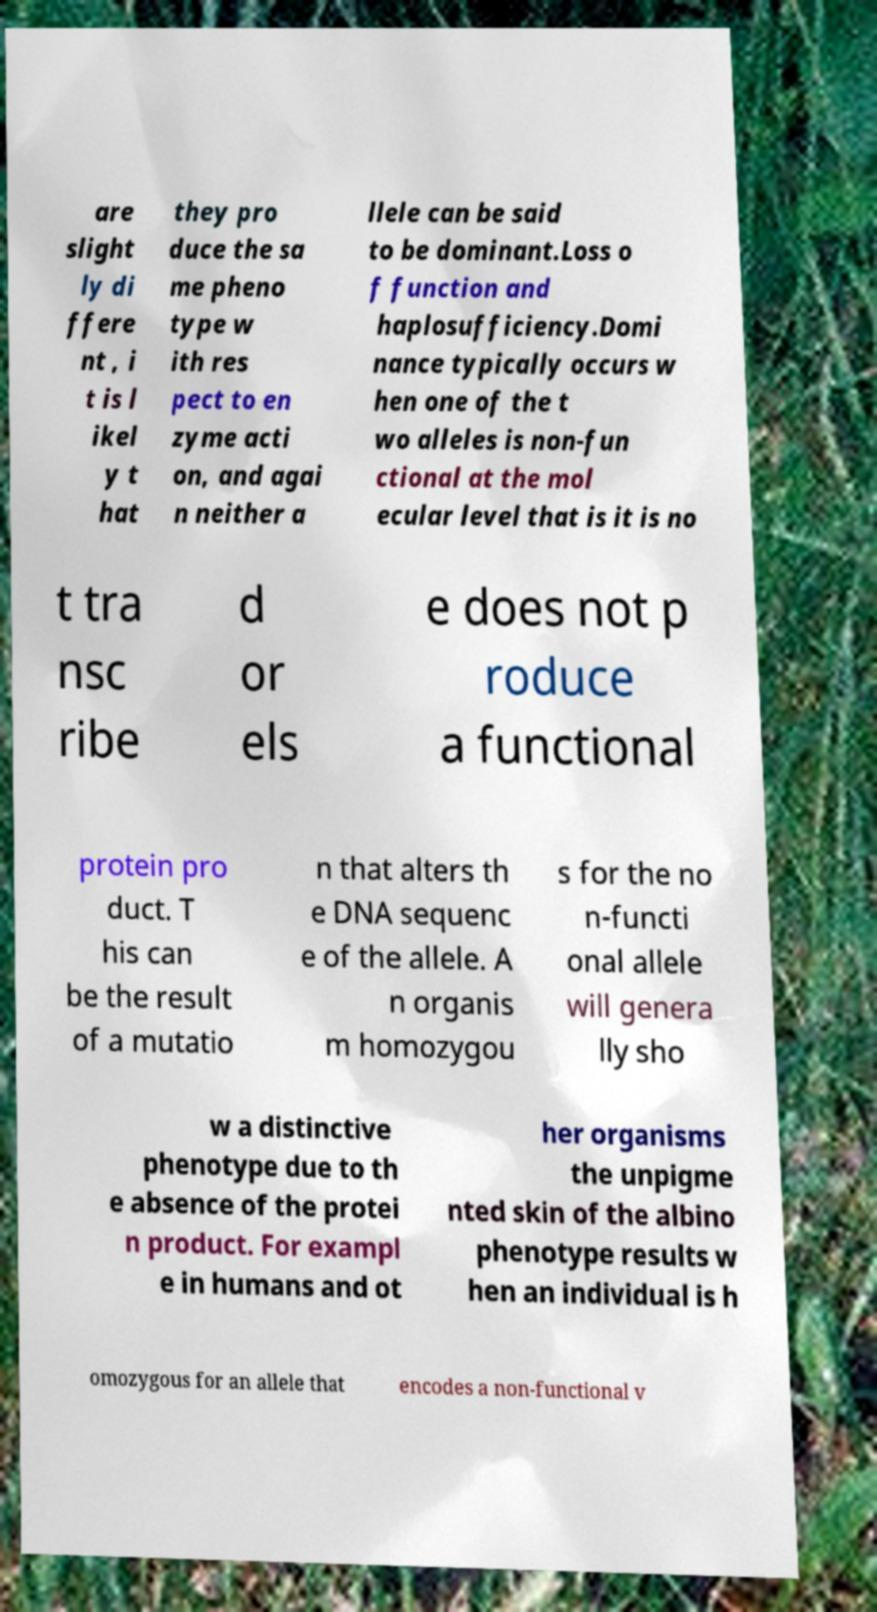For documentation purposes, I need the text within this image transcribed. Could you provide that? are slight ly di ffere nt , i t is l ikel y t hat they pro duce the sa me pheno type w ith res pect to en zyme acti on, and agai n neither a llele can be said to be dominant.Loss o f function and haplosufficiency.Domi nance typically occurs w hen one of the t wo alleles is non-fun ctional at the mol ecular level that is it is no t tra nsc ribe d or els e does not p roduce a functional protein pro duct. T his can be the result of a mutatio n that alters th e DNA sequenc e of the allele. A n organis m homozygou s for the no n-functi onal allele will genera lly sho w a distinctive phenotype due to th e absence of the protei n product. For exampl e in humans and ot her organisms the unpigme nted skin of the albino phenotype results w hen an individual is h omozygous for an allele that encodes a non-functional v 